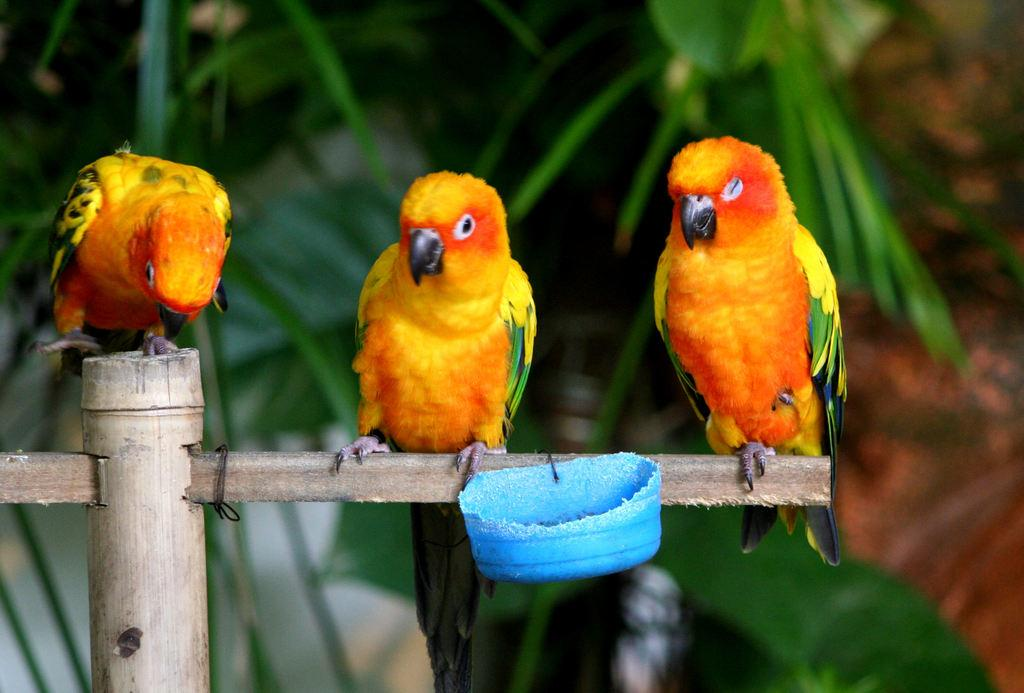How many birds are present in the image? There are three birds in the image. What are the birds perched on? The birds are on a wooden stick. Is there any container attached to the wooden stick? Yes, there is a small bowl attached to the wooden stick. What can be seen in the background of the image? Few leaves are visible in the background of the image. What type of planes can be seen flying in the image? There are no planes visible in the image; it features three birds on a wooden stick with a small bowl attached. How many balls are present in the image? There are no balls present in the image; it features three birds on a wooden stick with a small bowl attached. 